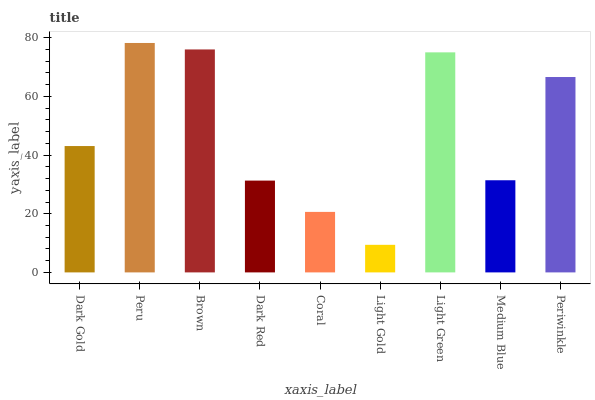Is Light Gold the minimum?
Answer yes or no. Yes. Is Peru the maximum?
Answer yes or no. Yes. Is Brown the minimum?
Answer yes or no. No. Is Brown the maximum?
Answer yes or no. No. Is Peru greater than Brown?
Answer yes or no. Yes. Is Brown less than Peru?
Answer yes or no. Yes. Is Brown greater than Peru?
Answer yes or no. No. Is Peru less than Brown?
Answer yes or no. No. Is Dark Gold the high median?
Answer yes or no. Yes. Is Dark Gold the low median?
Answer yes or no. Yes. Is Brown the high median?
Answer yes or no. No. Is Coral the low median?
Answer yes or no. No. 